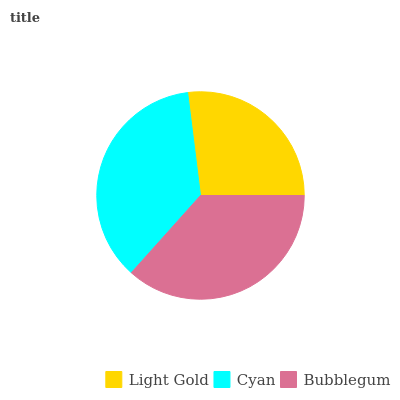Is Light Gold the minimum?
Answer yes or no. Yes. Is Bubblegum the maximum?
Answer yes or no. Yes. Is Cyan the minimum?
Answer yes or no. No. Is Cyan the maximum?
Answer yes or no. No. Is Cyan greater than Light Gold?
Answer yes or no. Yes. Is Light Gold less than Cyan?
Answer yes or no. Yes. Is Light Gold greater than Cyan?
Answer yes or no. No. Is Cyan less than Light Gold?
Answer yes or no. No. Is Cyan the high median?
Answer yes or no. Yes. Is Cyan the low median?
Answer yes or no. Yes. Is Bubblegum the high median?
Answer yes or no. No. Is Bubblegum the low median?
Answer yes or no. No. 